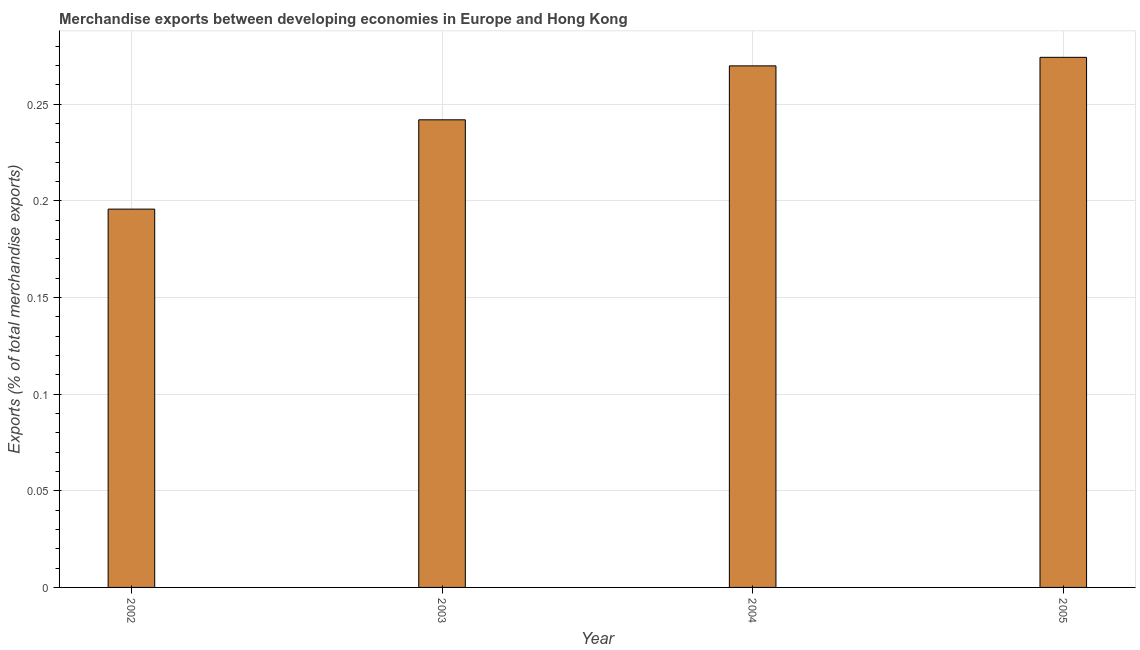What is the title of the graph?
Your response must be concise. Merchandise exports between developing economies in Europe and Hong Kong. What is the label or title of the X-axis?
Give a very brief answer. Year. What is the label or title of the Y-axis?
Provide a succinct answer. Exports (% of total merchandise exports). What is the merchandise exports in 2005?
Your response must be concise. 0.27. Across all years, what is the maximum merchandise exports?
Provide a short and direct response. 0.27. Across all years, what is the minimum merchandise exports?
Offer a very short reply. 0.2. In which year was the merchandise exports maximum?
Your answer should be compact. 2005. In which year was the merchandise exports minimum?
Your response must be concise. 2002. What is the sum of the merchandise exports?
Give a very brief answer. 0.98. What is the difference between the merchandise exports in 2003 and 2005?
Keep it short and to the point. -0.03. What is the average merchandise exports per year?
Your answer should be compact. 0.24. What is the median merchandise exports?
Your answer should be very brief. 0.26. In how many years, is the merchandise exports greater than 0.25 %?
Your answer should be compact. 2. Do a majority of the years between 2003 and 2005 (inclusive) have merchandise exports greater than 0.02 %?
Give a very brief answer. Yes. What is the ratio of the merchandise exports in 2002 to that in 2005?
Your answer should be compact. 0.71. Is the difference between the merchandise exports in 2003 and 2005 greater than the difference between any two years?
Keep it short and to the point. No. What is the difference between the highest and the second highest merchandise exports?
Your answer should be very brief. 0. Is the sum of the merchandise exports in 2003 and 2005 greater than the maximum merchandise exports across all years?
Your response must be concise. Yes. What is the difference between the highest and the lowest merchandise exports?
Keep it short and to the point. 0.08. In how many years, is the merchandise exports greater than the average merchandise exports taken over all years?
Offer a terse response. 2. How many years are there in the graph?
Offer a terse response. 4. What is the difference between two consecutive major ticks on the Y-axis?
Offer a terse response. 0.05. Are the values on the major ticks of Y-axis written in scientific E-notation?
Ensure brevity in your answer.  No. What is the Exports (% of total merchandise exports) of 2002?
Your answer should be very brief. 0.2. What is the Exports (% of total merchandise exports) in 2003?
Keep it short and to the point. 0.24. What is the Exports (% of total merchandise exports) of 2004?
Give a very brief answer. 0.27. What is the Exports (% of total merchandise exports) in 2005?
Provide a succinct answer. 0.27. What is the difference between the Exports (% of total merchandise exports) in 2002 and 2003?
Your answer should be compact. -0.05. What is the difference between the Exports (% of total merchandise exports) in 2002 and 2004?
Offer a very short reply. -0.07. What is the difference between the Exports (% of total merchandise exports) in 2002 and 2005?
Provide a succinct answer. -0.08. What is the difference between the Exports (% of total merchandise exports) in 2003 and 2004?
Your response must be concise. -0.03. What is the difference between the Exports (% of total merchandise exports) in 2003 and 2005?
Make the answer very short. -0.03. What is the difference between the Exports (% of total merchandise exports) in 2004 and 2005?
Offer a terse response. -0. What is the ratio of the Exports (% of total merchandise exports) in 2002 to that in 2003?
Your response must be concise. 0.81. What is the ratio of the Exports (% of total merchandise exports) in 2002 to that in 2004?
Your answer should be very brief. 0.72. What is the ratio of the Exports (% of total merchandise exports) in 2002 to that in 2005?
Make the answer very short. 0.71. What is the ratio of the Exports (% of total merchandise exports) in 2003 to that in 2004?
Offer a very short reply. 0.9. What is the ratio of the Exports (% of total merchandise exports) in 2003 to that in 2005?
Your response must be concise. 0.88. What is the ratio of the Exports (% of total merchandise exports) in 2004 to that in 2005?
Provide a succinct answer. 0.98. 